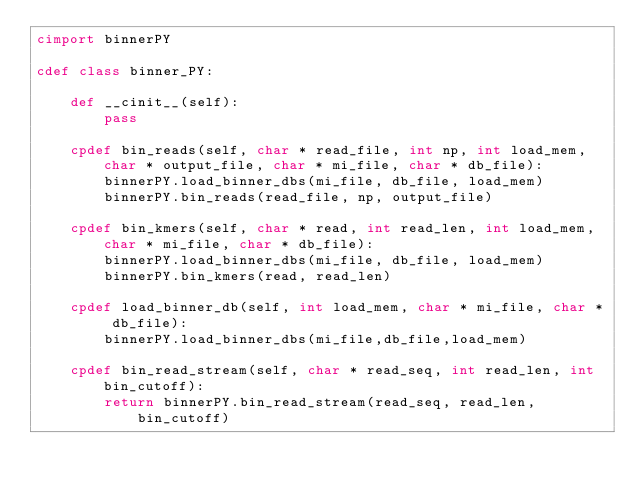<code> <loc_0><loc_0><loc_500><loc_500><_Cython_>cimport binnerPY

cdef class binner_PY:

	def __cinit__(self):
		pass

	cpdef bin_reads(self, char * read_file, int np, int load_mem, char * output_file, char * mi_file, char * db_file):
		binnerPY.load_binner_dbs(mi_file, db_file, load_mem)
		binnerPY.bin_reads(read_file, np, output_file)

	cpdef bin_kmers(self, char * read, int read_len, int load_mem, char * mi_file, char * db_file):
		binnerPY.load_binner_dbs(mi_file, db_file, load_mem)
		binnerPY.bin_kmers(read, read_len)

	cpdef load_binner_db(self, int load_mem, char * mi_file, char * db_file):
		binnerPY.load_binner_dbs(mi_file,db_file,load_mem)

	cpdef bin_read_stream(self, char * read_seq, int read_len, int bin_cutoff):
		return binnerPY.bin_read_stream(read_seq, read_len, bin_cutoff)
</code> 